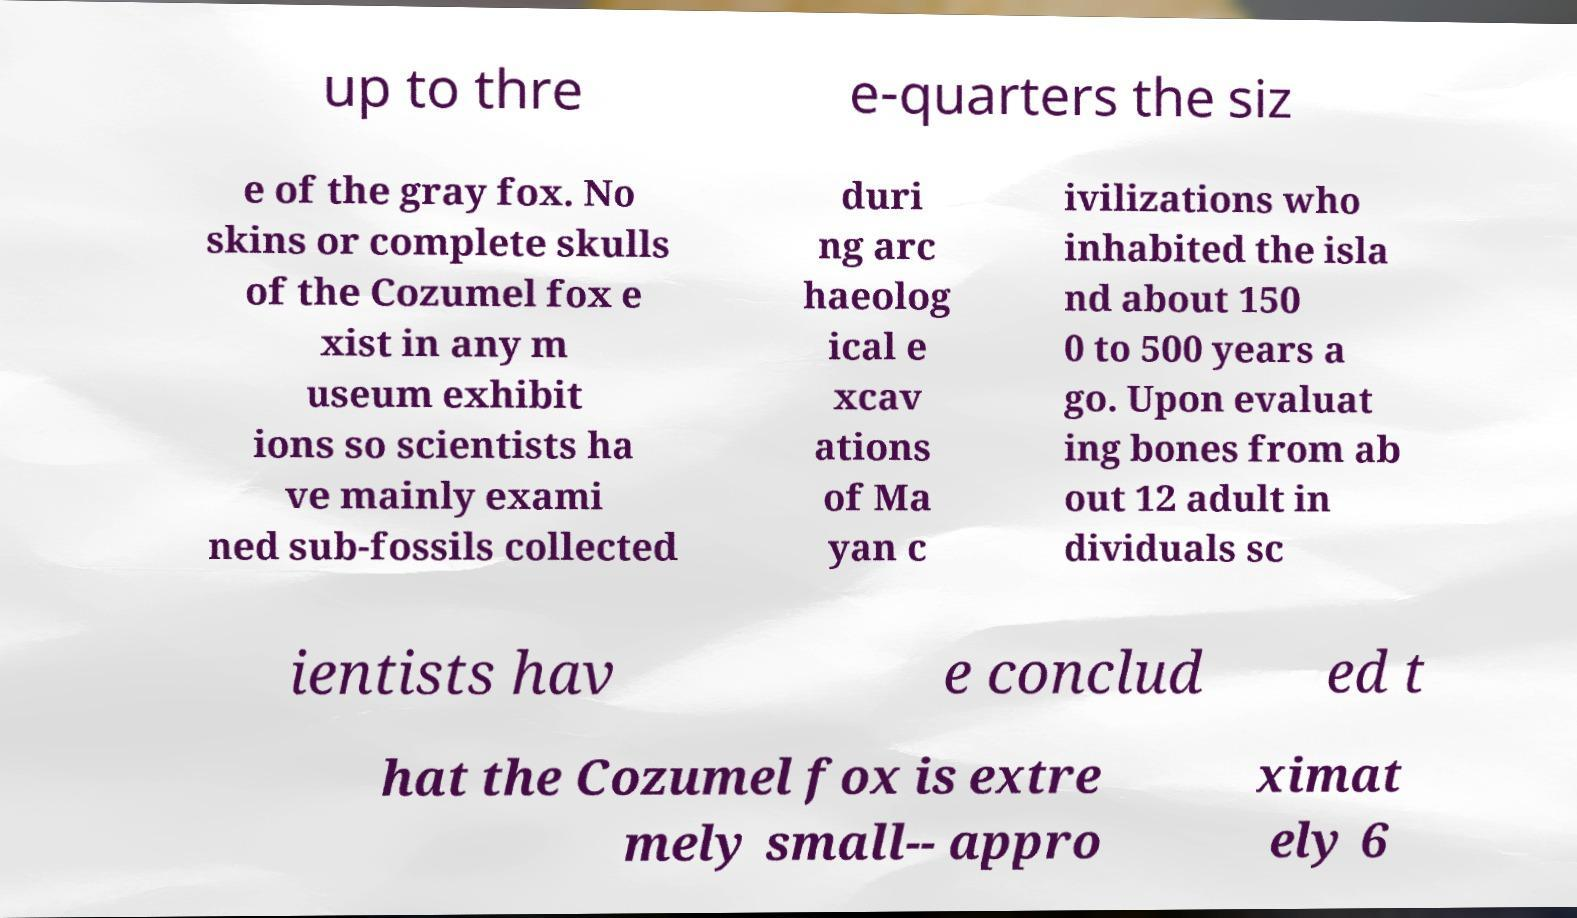Could you assist in decoding the text presented in this image and type it out clearly? up to thre e-quarters the siz e of the gray fox. No skins or complete skulls of the Cozumel fox e xist in any m useum exhibit ions so scientists ha ve mainly exami ned sub-fossils collected duri ng arc haeolog ical e xcav ations of Ma yan c ivilizations who inhabited the isla nd about 150 0 to 500 years a go. Upon evaluat ing bones from ab out 12 adult in dividuals sc ientists hav e conclud ed t hat the Cozumel fox is extre mely small-- appro ximat ely 6 